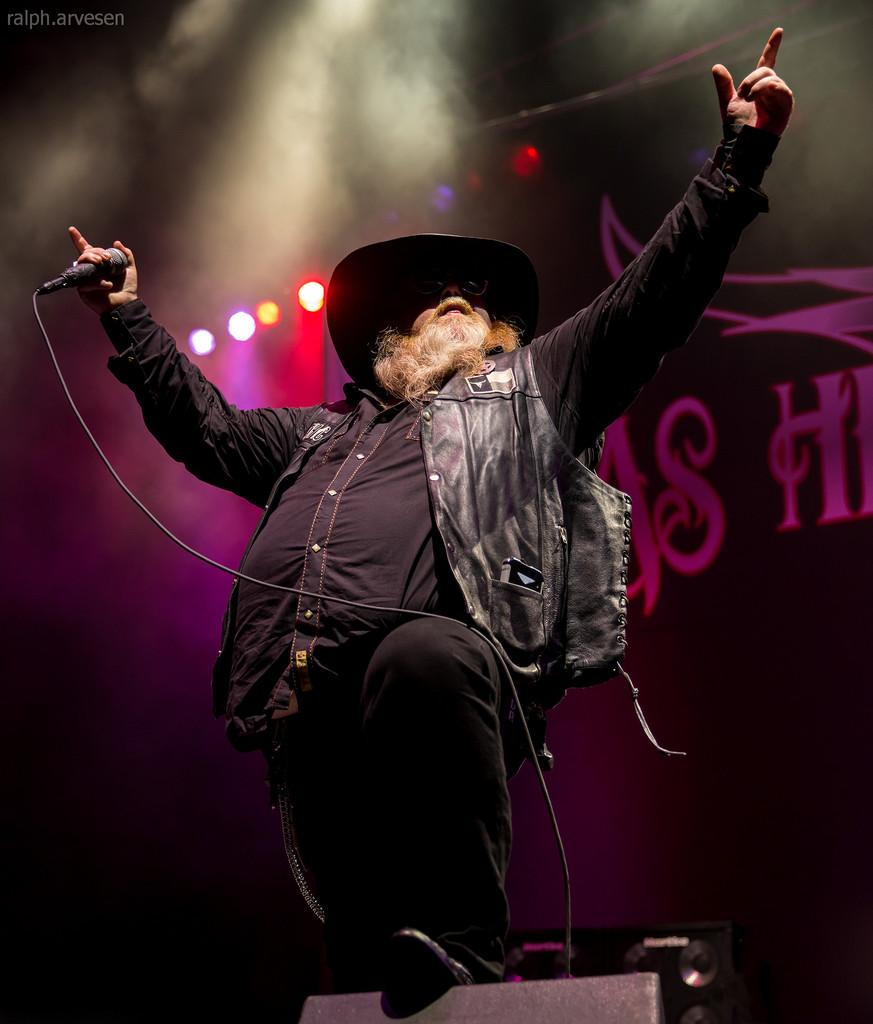What is the main subject of the image? There is a person in the image. What is the person holding in the image? The person is holding a mic. What can be seen in the background of the image? There are lights visible in the background of the image. What type of drink is the person holding in the image? There is no drink visible in the image; the person is holding a mic. Can you describe the jellyfish swimming in the background of the image? There are no jellyfish present in the image; the background features lights. 